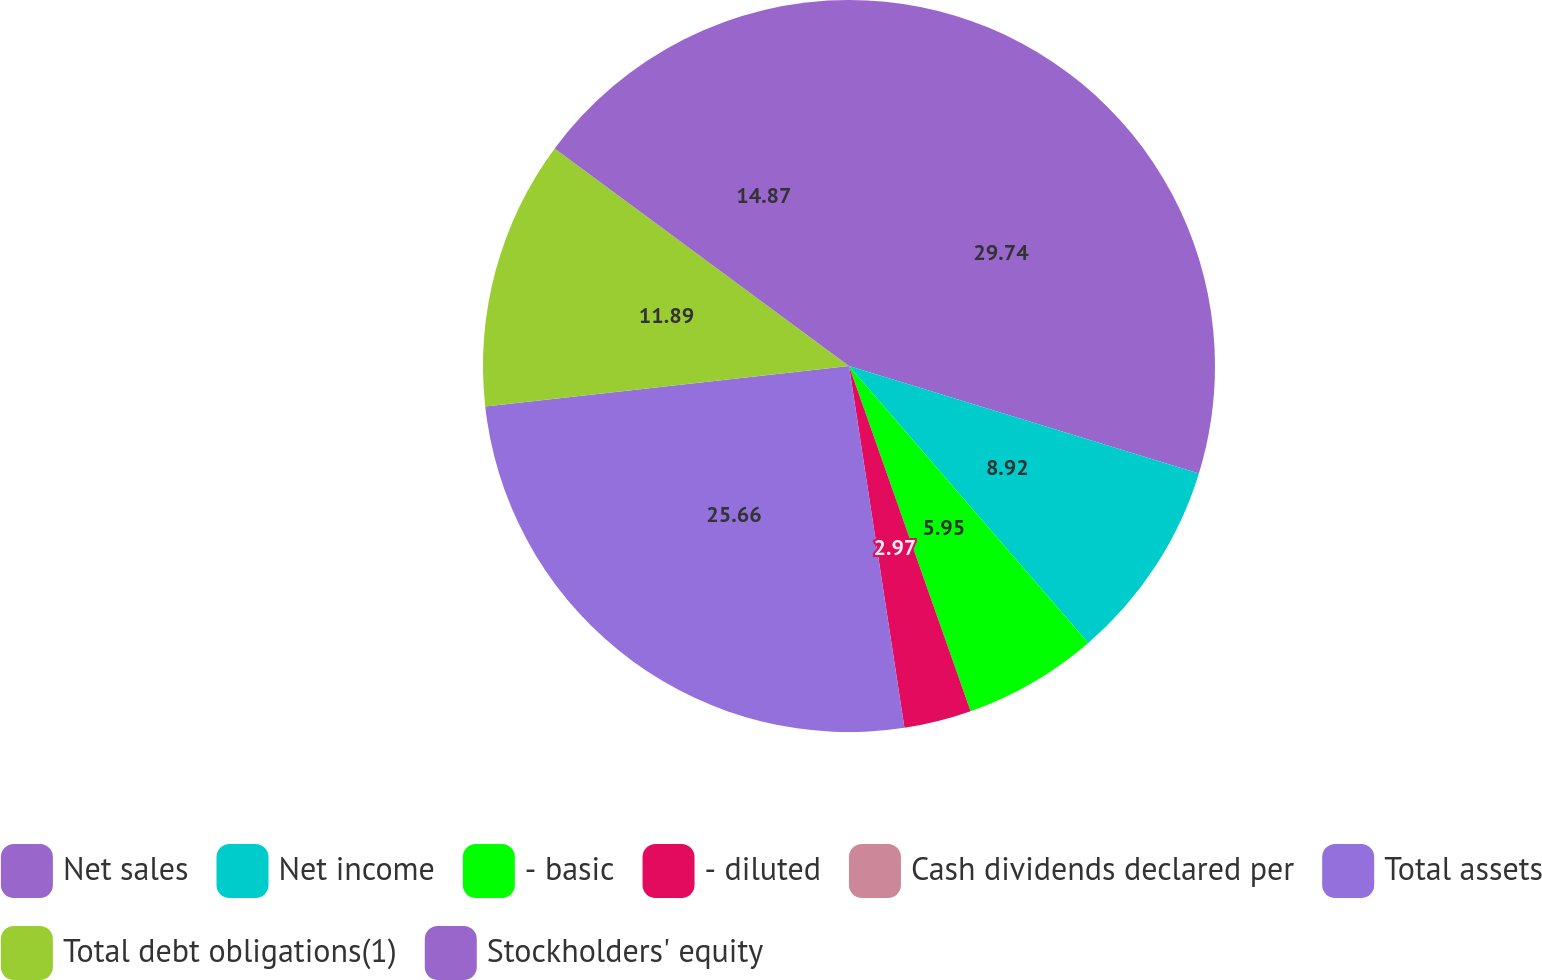<chart> <loc_0><loc_0><loc_500><loc_500><pie_chart><fcel>Net sales<fcel>Net income<fcel>- basic<fcel>- diluted<fcel>Cash dividends declared per<fcel>Total assets<fcel>Total debt obligations(1)<fcel>Stockholders' equity<nl><fcel>29.74%<fcel>8.92%<fcel>5.95%<fcel>2.97%<fcel>0.0%<fcel>25.66%<fcel>11.89%<fcel>14.87%<nl></chart> 